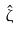Convert formula to latex. <formula><loc_0><loc_0><loc_500><loc_500>\hat { \zeta }</formula> 